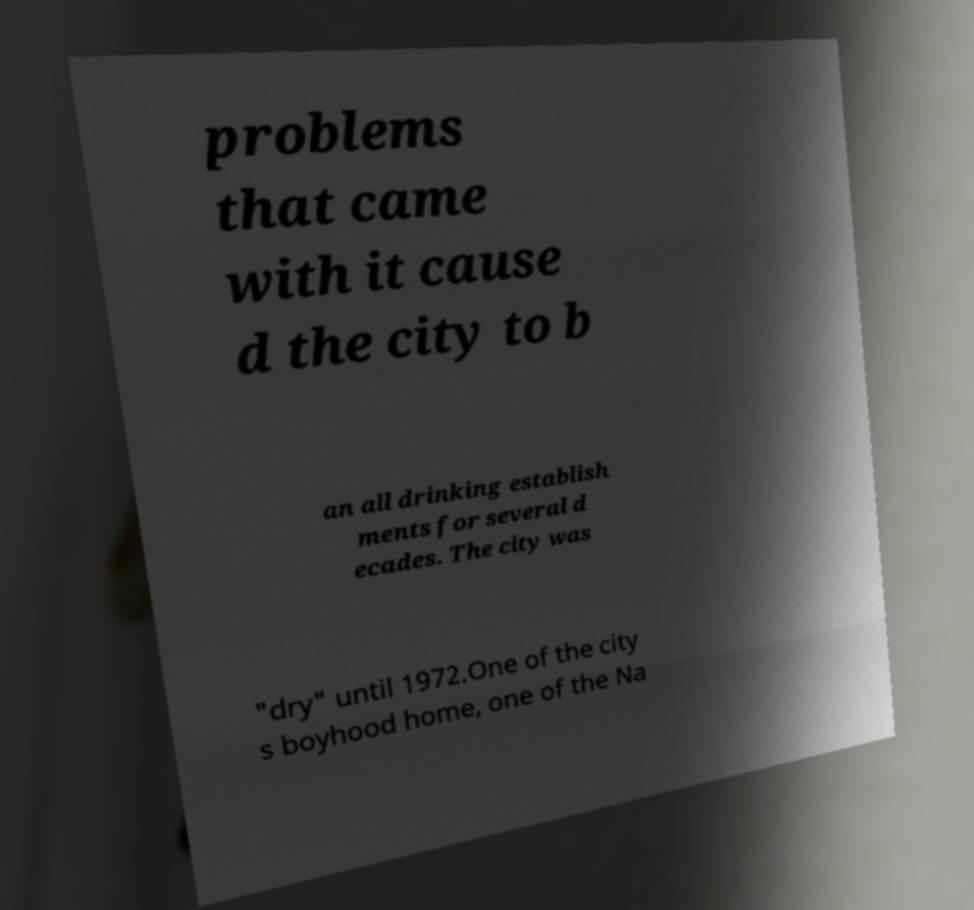Could you extract and type out the text from this image? problems that came with it cause d the city to b an all drinking establish ments for several d ecades. The city was "dry" until 1972.One of the city s boyhood home, one of the Na 